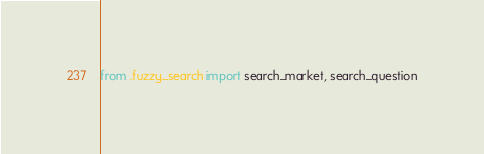Convert code to text. <code><loc_0><loc_0><loc_500><loc_500><_Python_>from .fuzzy_search import search_market, search_question
</code> 